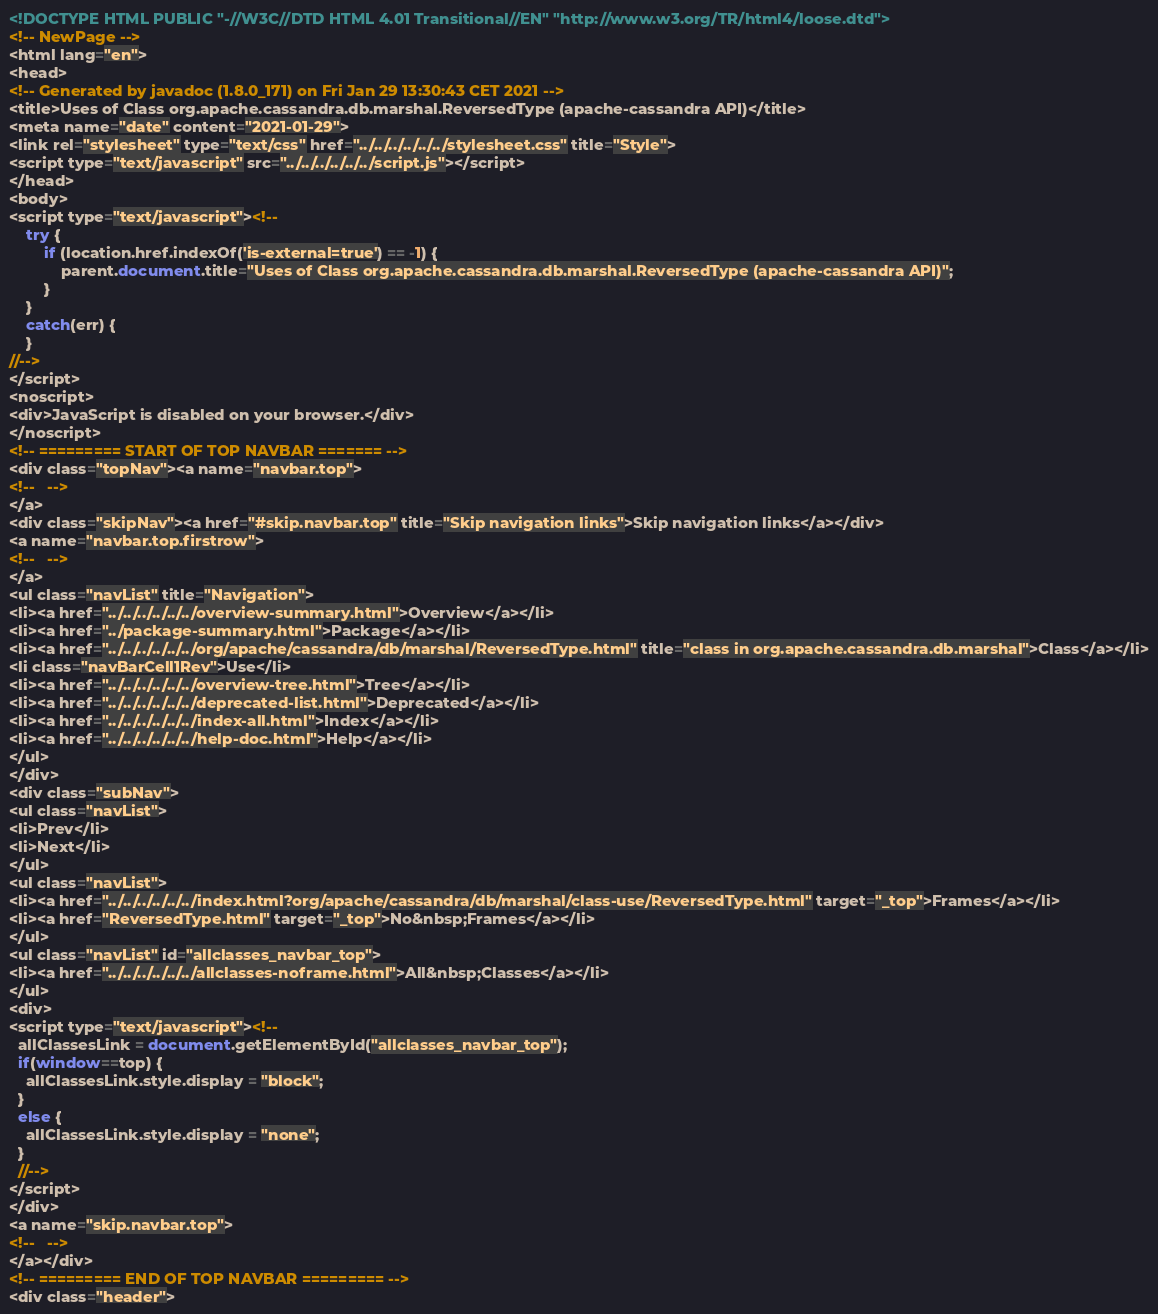<code> <loc_0><loc_0><loc_500><loc_500><_HTML_><!DOCTYPE HTML PUBLIC "-//W3C//DTD HTML 4.01 Transitional//EN" "http://www.w3.org/TR/html4/loose.dtd">
<!-- NewPage -->
<html lang="en">
<head>
<!-- Generated by javadoc (1.8.0_171) on Fri Jan 29 13:30:43 CET 2021 -->
<title>Uses of Class org.apache.cassandra.db.marshal.ReversedType (apache-cassandra API)</title>
<meta name="date" content="2021-01-29">
<link rel="stylesheet" type="text/css" href="../../../../../../stylesheet.css" title="Style">
<script type="text/javascript" src="../../../../../../script.js"></script>
</head>
<body>
<script type="text/javascript"><!--
    try {
        if (location.href.indexOf('is-external=true') == -1) {
            parent.document.title="Uses of Class org.apache.cassandra.db.marshal.ReversedType (apache-cassandra API)";
        }
    }
    catch(err) {
    }
//-->
</script>
<noscript>
<div>JavaScript is disabled on your browser.</div>
</noscript>
<!-- ========= START OF TOP NAVBAR ======= -->
<div class="topNav"><a name="navbar.top">
<!--   -->
</a>
<div class="skipNav"><a href="#skip.navbar.top" title="Skip navigation links">Skip navigation links</a></div>
<a name="navbar.top.firstrow">
<!--   -->
</a>
<ul class="navList" title="Navigation">
<li><a href="../../../../../../overview-summary.html">Overview</a></li>
<li><a href="../package-summary.html">Package</a></li>
<li><a href="../../../../../../org/apache/cassandra/db/marshal/ReversedType.html" title="class in org.apache.cassandra.db.marshal">Class</a></li>
<li class="navBarCell1Rev">Use</li>
<li><a href="../../../../../../overview-tree.html">Tree</a></li>
<li><a href="../../../../../../deprecated-list.html">Deprecated</a></li>
<li><a href="../../../../../../index-all.html">Index</a></li>
<li><a href="../../../../../../help-doc.html">Help</a></li>
</ul>
</div>
<div class="subNav">
<ul class="navList">
<li>Prev</li>
<li>Next</li>
</ul>
<ul class="navList">
<li><a href="../../../../../../index.html?org/apache/cassandra/db/marshal/class-use/ReversedType.html" target="_top">Frames</a></li>
<li><a href="ReversedType.html" target="_top">No&nbsp;Frames</a></li>
</ul>
<ul class="navList" id="allclasses_navbar_top">
<li><a href="../../../../../../allclasses-noframe.html">All&nbsp;Classes</a></li>
</ul>
<div>
<script type="text/javascript"><!--
  allClassesLink = document.getElementById("allclasses_navbar_top");
  if(window==top) {
    allClassesLink.style.display = "block";
  }
  else {
    allClassesLink.style.display = "none";
  }
  //-->
</script>
</div>
<a name="skip.navbar.top">
<!--   -->
</a></div>
<!-- ========= END OF TOP NAVBAR ========= -->
<div class="header"></code> 